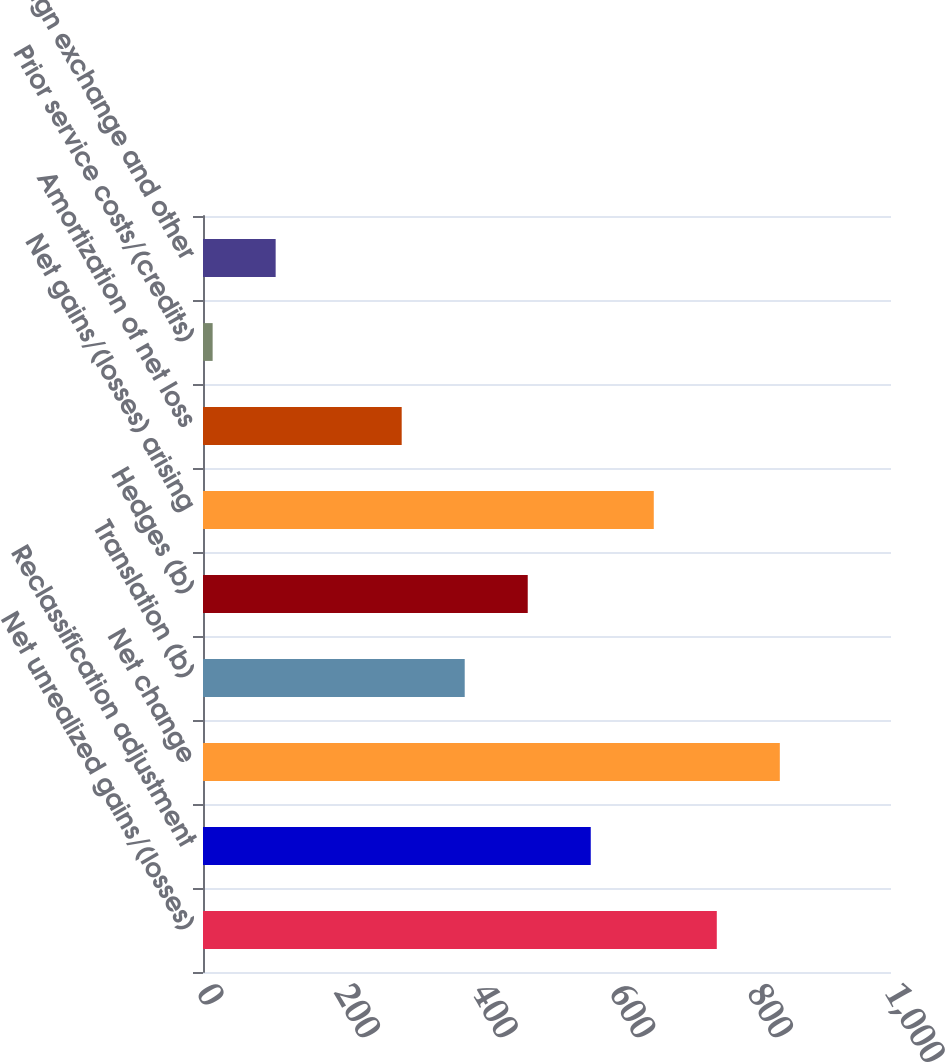Convert chart to OTSL. <chart><loc_0><loc_0><loc_500><loc_500><bar_chart><fcel>Net unrealized gains/(losses)<fcel>Reclassification adjustment<fcel>Net change<fcel>Translation (b)<fcel>Hedges (b)<fcel>Net gains/(losses) arising<fcel>Amortization of net loss<fcel>Prior service costs/(credits)<fcel>Foreign exchange and other<nl><fcel>746.8<fcel>563.6<fcel>838.4<fcel>380.4<fcel>472<fcel>655.2<fcel>288.8<fcel>14<fcel>105.6<nl></chart> 